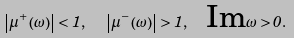<formula> <loc_0><loc_0><loc_500><loc_500>\left | \mu ^ { + } \left ( \omega \right ) \right | < 1 , \text { \ } \left | \mu ^ { - } \left ( \omega \right ) \right | > 1 , \text { \ Im} \omega > 0 .</formula> 